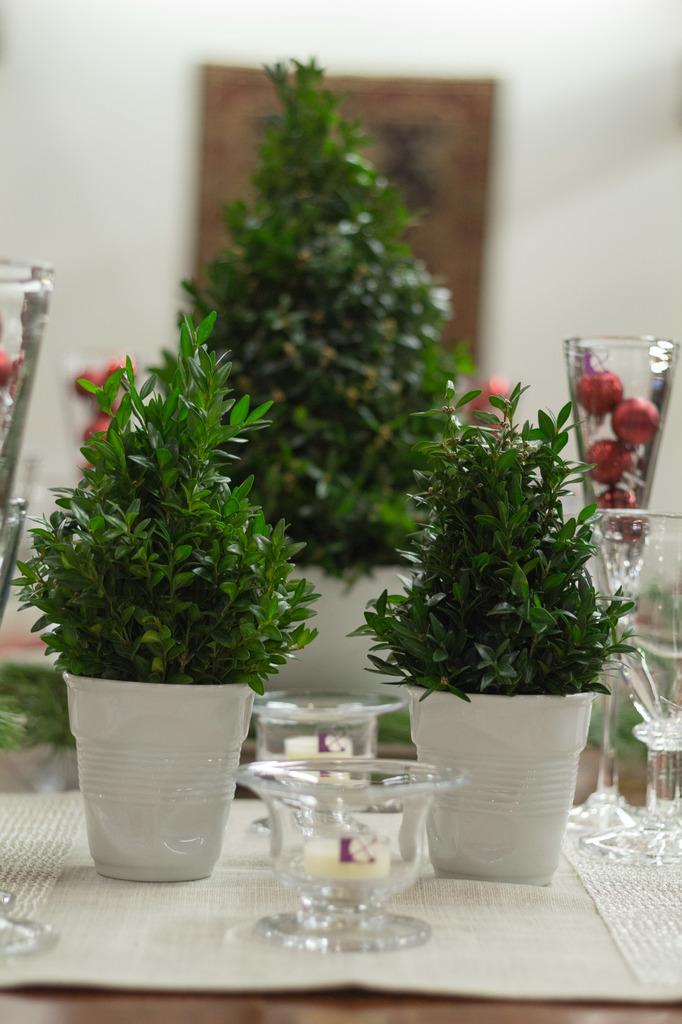What type of plants are in the pots in the image? There are trees in pots in the image. Where are the pots with trees located? The pots are placed on a table in the image. What color is the background of the image? The background of the image is white in color. Is there any additional material attached to the background? Yes, there is a mat attached to the background. What type of yarn is being used to support the trees in the pots? There is no yarn present in the image; the trees in pots are supported by the soil in the pots. 